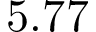Convert formula to latex. <formula><loc_0><loc_0><loc_500><loc_500>5 . 7 7</formula> 